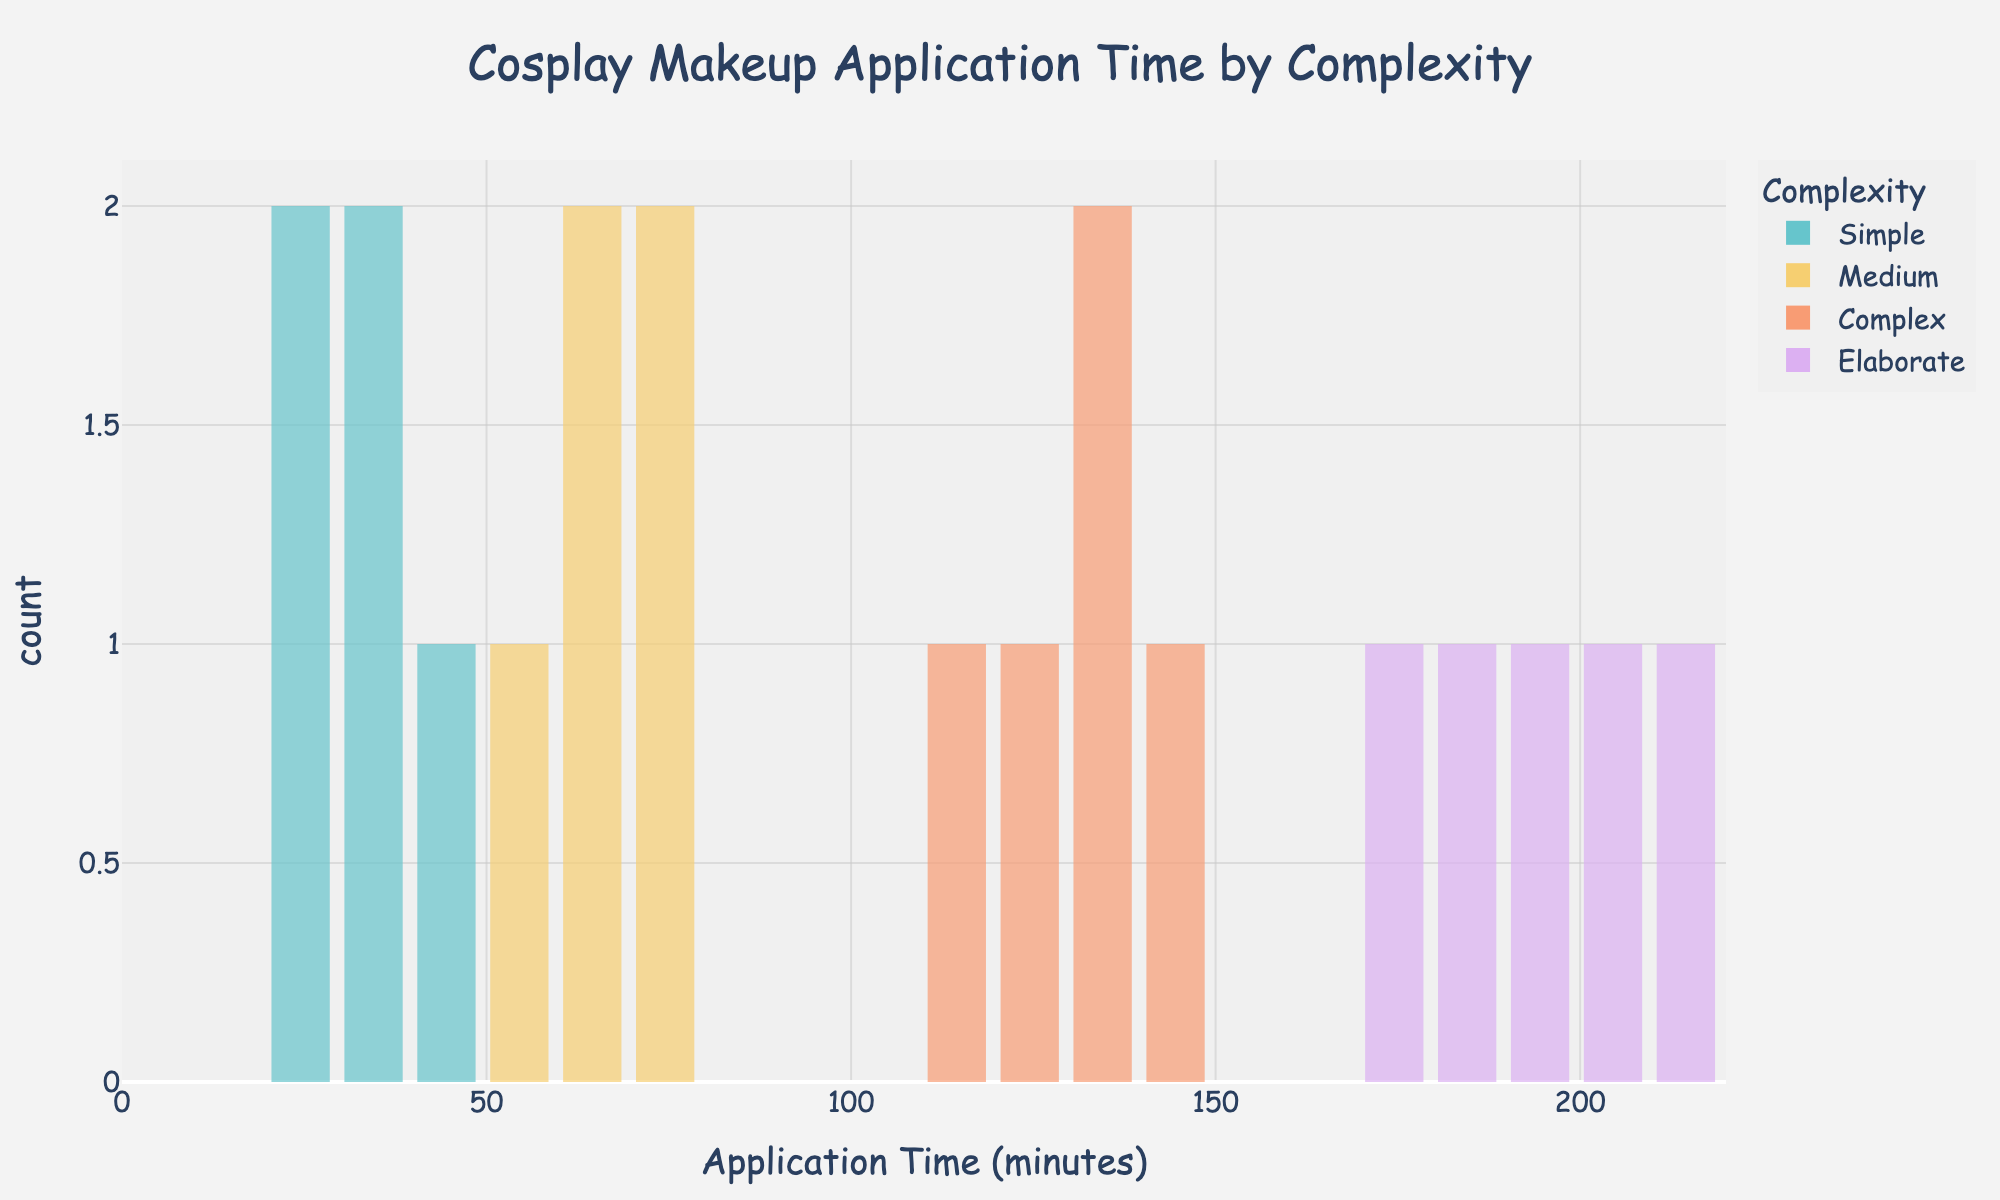How many different complexities are shown in the histogram? The title and legend indicate the categories, and we observe four distinct colors representing different complexities. These are labeled as Simple, Medium, Complex, and Elaborate.
Answer: 4 What is the range of time spent for "Simple" complexity makeup? By observing the histogram, the bars for "Simple" complexity fall between 20 to 40 minutes.
Answer: 20 to 40 minutes Which complexity category has the widest variation in time spent on makeup application? The bars for "Elaborate" complexity span a wide range, from 170 to 210 minutes, indicating it has the widest variation.
Answer: Elaborate What is the median time spent on "Complex" makeup applications? Ordering the times for "Complex" (110, 120, 130, 135, 145), the median is the middle number, which is 130 minutes.
Answer: 130 minutes Between "Medium" and "Complex" categories, which one has the higher average time spent on makeup application? First, calculate the average for Medium (60+55+70+65+75=325; 325/5=65) and Complex (120+110+135+145+130=640; 640/5=128) complexities. Compare 65 and 128.
Answer: Complex How does the number of data points in the "Simple" category compare to the "Elaborate" category? Count the bars for each category from the histogram. Both "Simple" and "Elaborate" have 5 data points each.
Answer: Equal (5 each) What does the peak frequency of the "Elaborate" category indicate? The histogram shows the most frequent time intervals for Elaborate complexity are around 190-200 minutes.
Answer: 190-200 minutes If a customer requests a "Medium" complexity makeup, what typical time range should you prepare to spend? From the histogram, the time range for "Medium" complexity spans from 55 to 75 minutes.
Answer: 55 to 75 minutes 